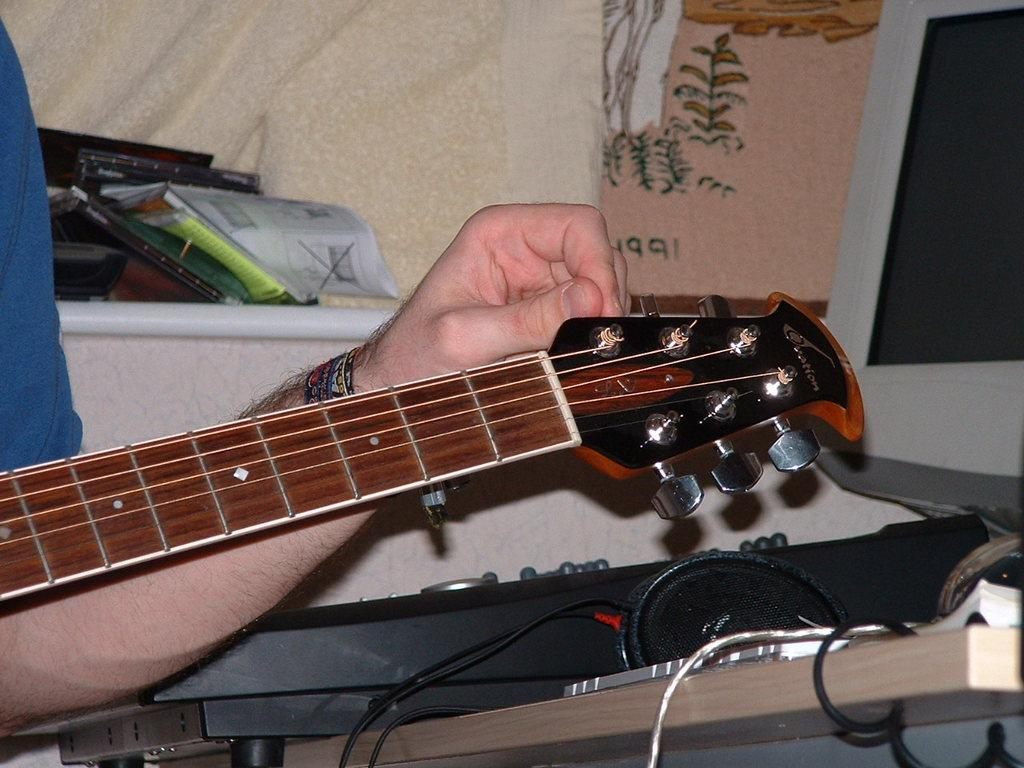What is the main subject of the image? There is a person in the image. What is the person holding in the image? The person is holding a guitar. What type of crib is visible in the image? There is no crib present in the image. What room is the person in while holding the guitar? The image does not provide information about the room or location where the person is holding the guitar. 